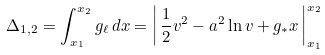<formula> <loc_0><loc_0><loc_500><loc_500>\Delta _ { 1 , 2 } = \int _ { x _ { 1 } } ^ { x _ { 2 } } g _ { \ell } \, d x = \left | \, \frac { 1 } { 2 } v ^ { 2 } - a ^ { 2 } \ln v + g _ { * } x \, \right | _ { x _ { 1 } } ^ { x _ { 2 } }</formula> 